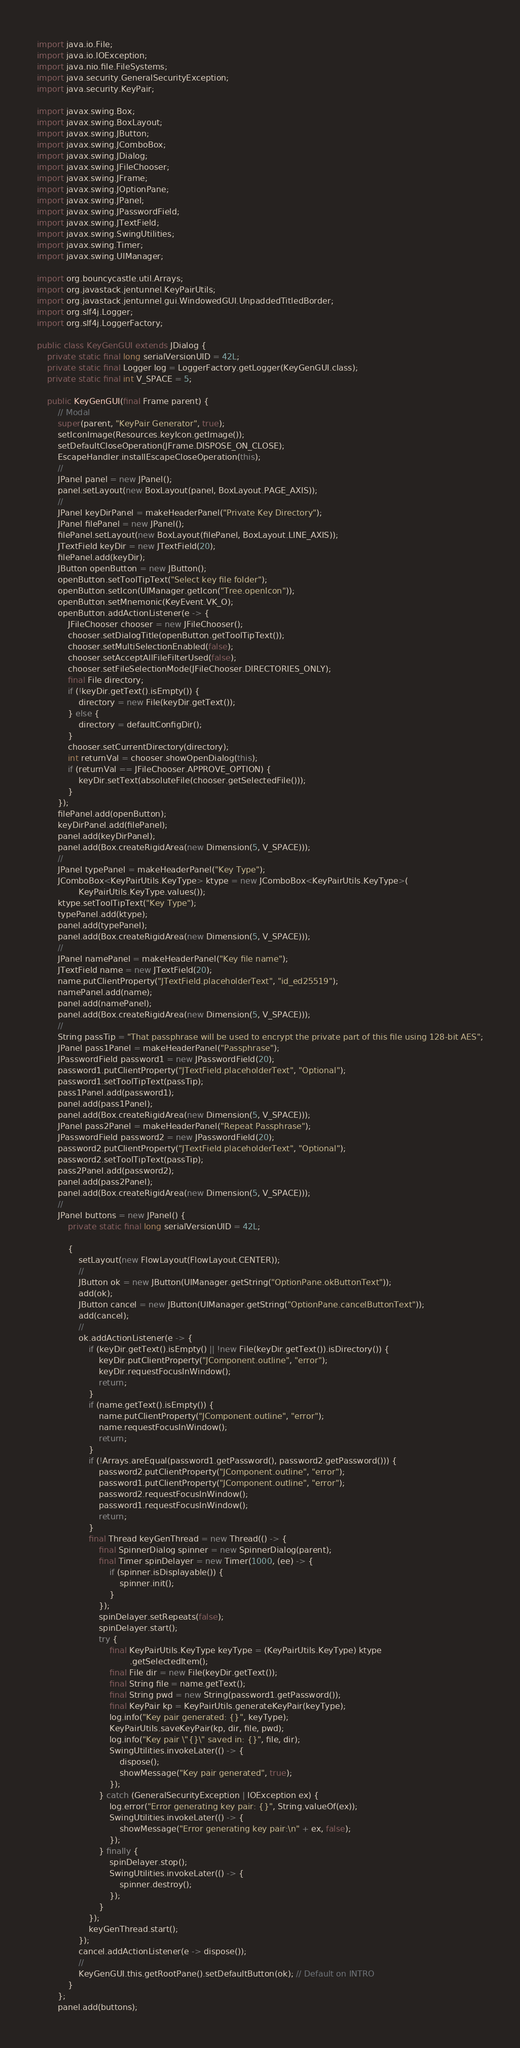<code> <loc_0><loc_0><loc_500><loc_500><_Java_>import java.io.File;
import java.io.IOException;
import java.nio.file.FileSystems;
import java.security.GeneralSecurityException;
import java.security.KeyPair;

import javax.swing.Box;
import javax.swing.BoxLayout;
import javax.swing.JButton;
import javax.swing.JComboBox;
import javax.swing.JDialog;
import javax.swing.JFileChooser;
import javax.swing.JFrame;
import javax.swing.JOptionPane;
import javax.swing.JPanel;
import javax.swing.JPasswordField;
import javax.swing.JTextField;
import javax.swing.SwingUtilities;
import javax.swing.Timer;
import javax.swing.UIManager;

import org.bouncycastle.util.Arrays;
import org.javastack.jentunnel.KeyPairUtils;
import org.javastack.jentunnel.gui.WindowedGUI.UnpaddedTitledBorder;
import org.slf4j.Logger;
import org.slf4j.LoggerFactory;

public class KeyGenGUI extends JDialog {
	private static final long serialVersionUID = 42L;
	private static final Logger log = LoggerFactory.getLogger(KeyGenGUI.class);
	private static final int V_SPACE = 5;

	public KeyGenGUI(final Frame parent) {
		// Modal
		super(parent, "KeyPair Generator", true);
		setIconImage(Resources.keyIcon.getImage());
		setDefaultCloseOperation(JFrame.DISPOSE_ON_CLOSE);
		EscapeHandler.installEscapeCloseOperation(this);
		//
		JPanel panel = new JPanel();
		panel.setLayout(new BoxLayout(panel, BoxLayout.PAGE_AXIS));
		//
		JPanel keyDirPanel = makeHeaderPanel("Private Key Directory");
		JPanel filePanel = new JPanel();
		filePanel.setLayout(new BoxLayout(filePanel, BoxLayout.LINE_AXIS));
		JTextField keyDir = new JTextField(20);
		filePanel.add(keyDir);
		JButton openButton = new JButton();
		openButton.setToolTipText("Select key file folder");
		openButton.setIcon(UIManager.getIcon("Tree.openIcon"));
		openButton.setMnemonic(KeyEvent.VK_O);
		openButton.addActionListener(e -> {
			JFileChooser chooser = new JFileChooser();
			chooser.setDialogTitle(openButton.getToolTipText());
			chooser.setMultiSelectionEnabled(false);
			chooser.setAcceptAllFileFilterUsed(false);
			chooser.setFileSelectionMode(JFileChooser.DIRECTORIES_ONLY);
			final File directory;
			if (!keyDir.getText().isEmpty()) {
				directory = new File(keyDir.getText());
			} else {
				directory = defaultConfigDir();
			}
			chooser.setCurrentDirectory(directory);
			int returnVal = chooser.showOpenDialog(this);
			if (returnVal == JFileChooser.APPROVE_OPTION) {
				keyDir.setText(absoluteFile(chooser.getSelectedFile()));
			}
		});
		filePanel.add(openButton);
		keyDirPanel.add(filePanel);
		panel.add(keyDirPanel);
		panel.add(Box.createRigidArea(new Dimension(5, V_SPACE)));
		//
		JPanel typePanel = makeHeaderPanel("Key Type");
		JComboBox<KeyPairUtils.KeyType> ktype = new JComboBox<KeyPairUtils.KeyType>(
				KeyPairUtils.KeyType.values());
		ktype.setToolTipText("Key Type");
		typePanel.add(ktype);
		panel.add(typePanel);
		panel.add(Box.createRigidArea(new Dimension(5, V_SPACE)));
		//
		JPanel namePanel = makeHeaderPanel("Key file name");
		JTextField name = new JTextField(20);
		name.putClientProperty("JTextField.placeholderText", "id_ed25519");
		namePanel.add(name);
		panel.add(namePanel);
		panel.add(Box.createRigidArea(new Dimension(5, V_SPACE)));
		//
		String passTip = "That passphrase will be used to encrypt the private part of this file using 128-bit AES";
		JPanel pass1Panel = makeHeaderPanel("Passphrase");
		JPasswordField password1 = new JPasswordField(20);
		password1.putClientProperty("JTextField.placeholderText", "Optional");
		password1.setToolTipText(passTip);
		pass1Panel.add(password1);
		panel.add(pass1Panel);
		panel.add(Box.createRigidArea(new Dimension(5, V_SPACE)));
		JPanel pass2Panel = makeHeaderPanel("Repeat Passphrase");
		JPasswordField password2 = new JPasswordField(20);
		password2.putClientProperty("JTextField.placeholderText", "Optional");
		password2.setToolTipText(passTip);
		pass2Panel.add(password2);
		panel.add(pass2Panel);
		panel.add(Box.createRigidArea(new Dimension(5, V_SPACE)));
		//
		JPanel buttons = new JPanel() {
			private static final long serialVersionUID = 42L;

			{
				setLayout(new FlowLayout(FlowLayout.CENTER));
				//
				JButton ok = new JButton(UIManager.getString("OptionPane.okButtonText"));
				add(ok);
				JButton cancel = new JButton(UIManager.getString("OptionPane.cancelButtonText"));
				add(cancel);
				//
				ok.addActionListener(e -> {
					if (keyDir.getText().isEmpty() || !new File(keyDir.getText()).isDirectory()) {
						keyDir.putClientProperty("JComponent.outline", "error");
						keyDir.requestFocusInWindow();
						return;
					}
					if (name.getText().isEmpty()) {
						name.putClientProperty("JComponent.outline", "error");
						name.requestFocusInWindow();
						return;
					}
					if (!Arrays.areEqual(password1.getPassword(), password2.getPassword())) {
						password2.putClientProperty("JComponent.outline", "error");
						password1.putClientProperty("JComponent.outline", "error");
						password2.requestFocusInWindow();
						password1.requestFocusInWindow();
						return;
					}
					final Thread keyGenThread = new Thread(() -> {
						final SpinnerDialog spinner = new SpinnerDialog(parent);
						final Timer spinDelayer = new Timer(1000, (ee) -> {
							if (spinner.isDisplayable()) {
								spinner.init();
							}
						});
						spinDelayer.setRepeats(false);
						spinDelayer.start();
						try {
							final KeyPairUtils.KeyType keyType = (KeyPairUtils.KeyType) ktype
									.getSelectedItem();
							final File dir = new File(keyDir.getText());
							final String file = name.getText();
							final String pwd = new String(password1.getPassword());
							final KeyPair kp = KeyPairUtils.generateKeyPair(keyType);
							log.info("Key pair generated: {}", keyType);
							KeyPairUtils.saveKeyPair(kp, dir, file, pwd);
							log.info("Key pair \"{}\" saved in: {}", file, dir);
							SwingUtilities.invokeLater(() -> {
								dispose();
								showMessage("Key pair generated", true);
							});
						} catch (GeneralSecurityException | IOException ex) {
							log.error("Error generating key pair: {}", String.valueOf(ex));
							SwingUtilities.invokeLater(() -> {
								showMessage("Error generating key pair:\n" + ex, false);
							});
						} finally {
							spinDelayer.stop();
							SwingUtilities.invokeLater(() -> {
								spinner.destroy();
							});
						}
					});
					keyGenThread.start();
				});
				cancel.addActionListener(e -> dispose());
				//
				KeyGenGUI.this.getRootPane().setDefaultButton(ok); // Default on INTRO
			}
		};
		panel.add(buttons);</code> 